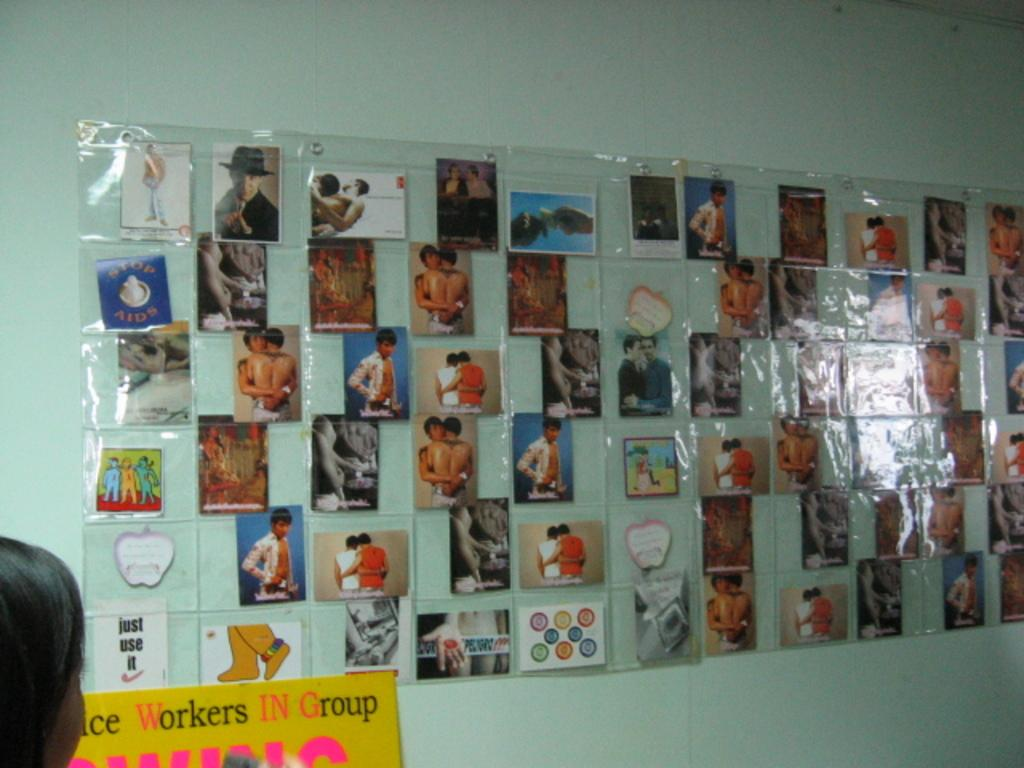What can be seen on the wall in the image? There are photos laminated on the wall in the image. Can you describe the person's head visible in the image? There is a person's head visible in the left bottom corner of the image. What is written on the board in the image? Unfortunately, the specific content of what is written on the board cannot be determined from the provided facts. What type of lumber is being sold at the market in the image? There is no market or lumber present in the image; it features photos laminated on a wall and a person's head in the corner. How does the comparison between the two photos on the wall differ in the image? There is no comparison between two photos mentioned in the provided facts, so it cannot be determined from the image. 